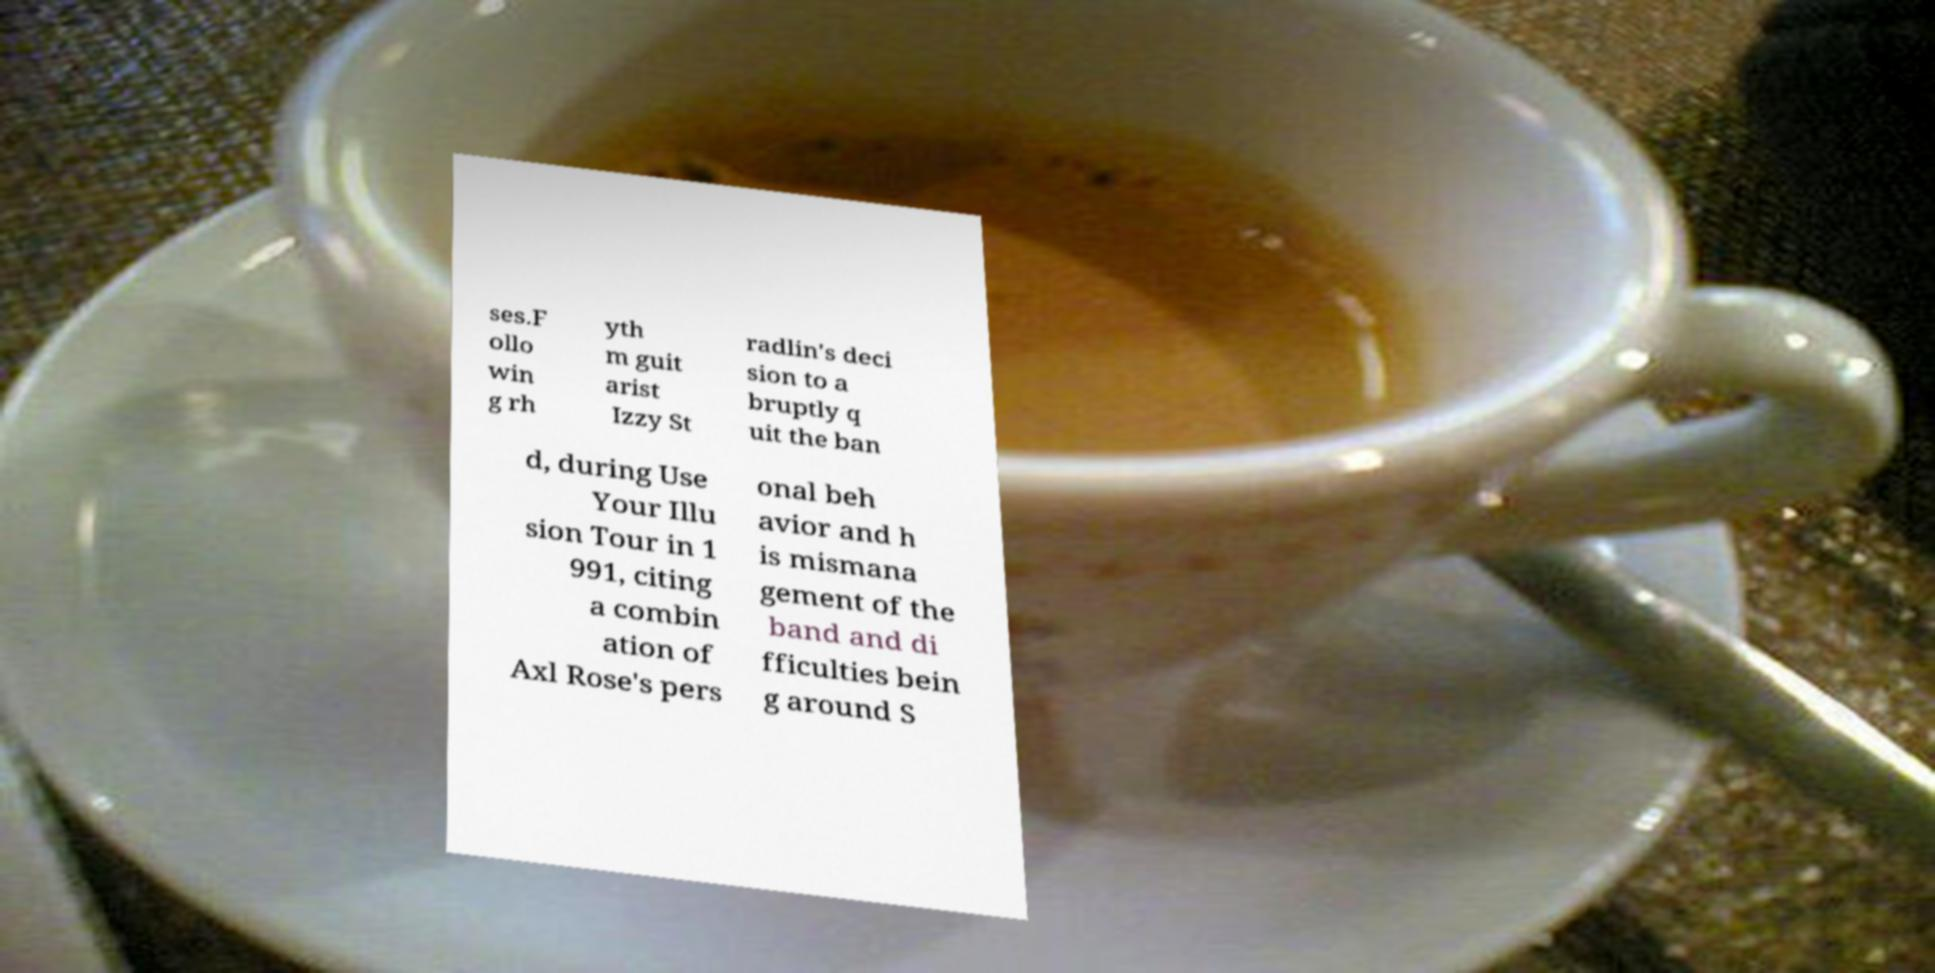Can you accurately transcribe the text from the provided image for me? ses.F ollo win g rh yth m guit arist Izzy St radlin's deci sion to a bruptly q uit the ban d, during Use Your Illu sion Tour in 1 991, citing a combin ation of Axl Rose's pers onal beh avior and h is mismana gement of the band and di fficulties bein g around S 